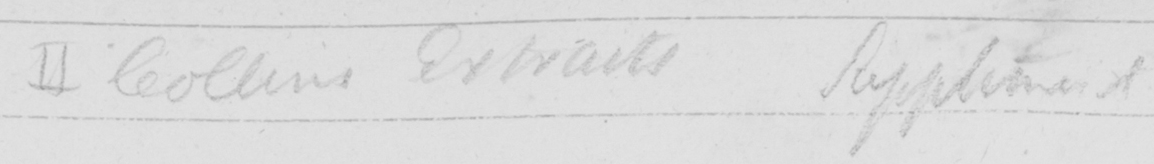What is written in this line of handwriting? II Collins Extracts Supplement 